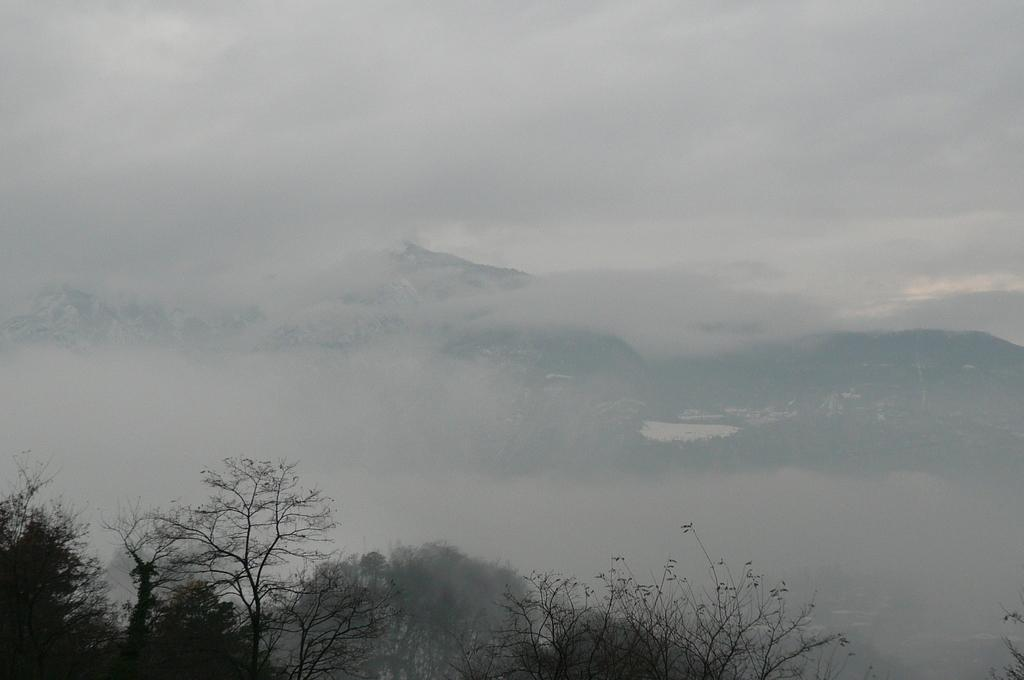What type of vegetation is at the bottom of the image? There are trees at the bottom of the image. What can be seen in the background of the image? There is fog, mountains, and clouds in the sky in the background of the image. How many apples are hanging from the trees in the image? There are no apples present in the image; it features trees, fog, mountains, and clouds. What type of road can be seen in the image? There is no road present in the image. 